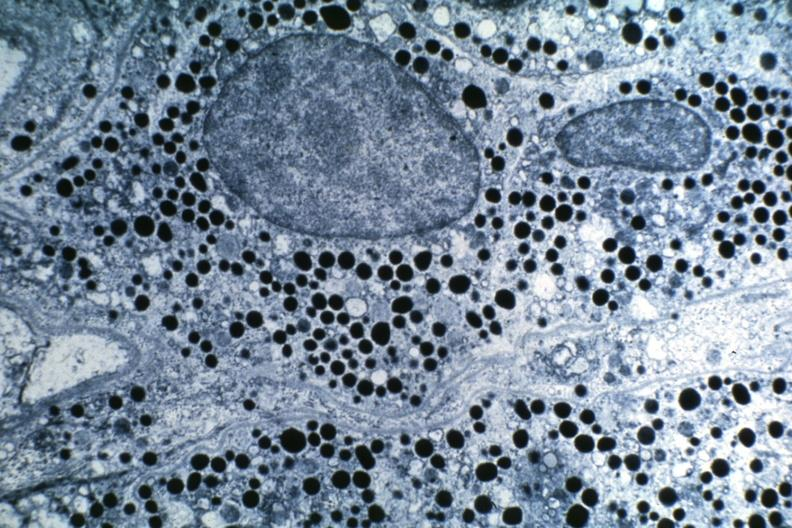s adenoma present?
Answer the question using a single word or phrase. Yes 